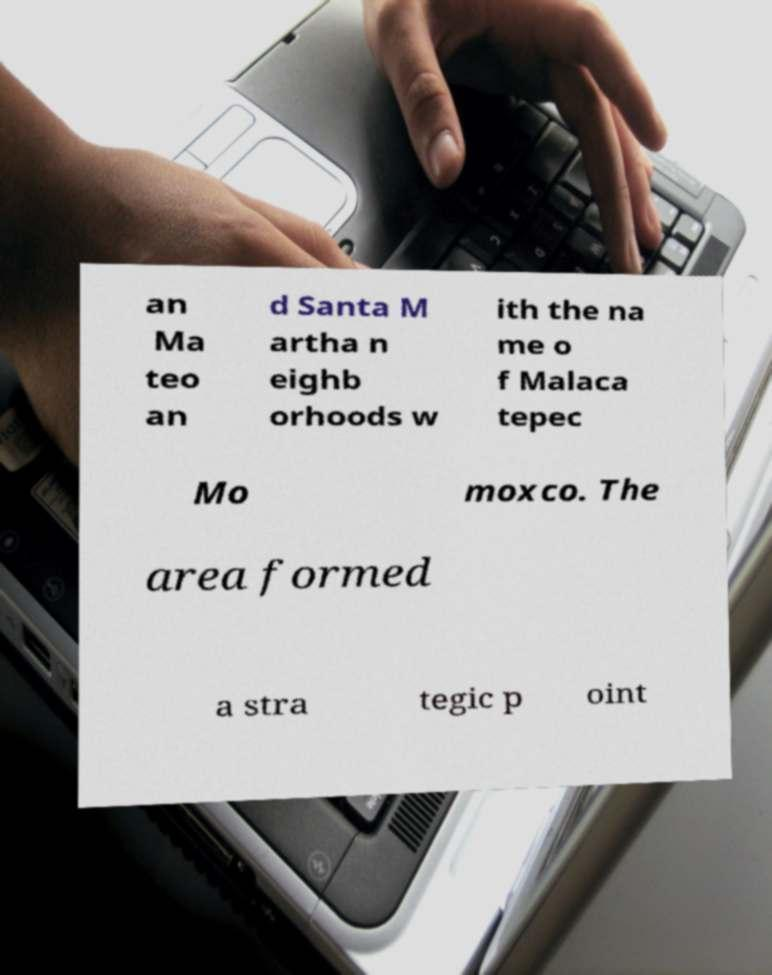For documentation purposes, I need the text within this image transcribed. Could you provide that? an Ma teo an d Santa M artha n eighb orhoods w ith the na me o f Malaca tepec Mo moxco. The area formed a stra tegic p oint 